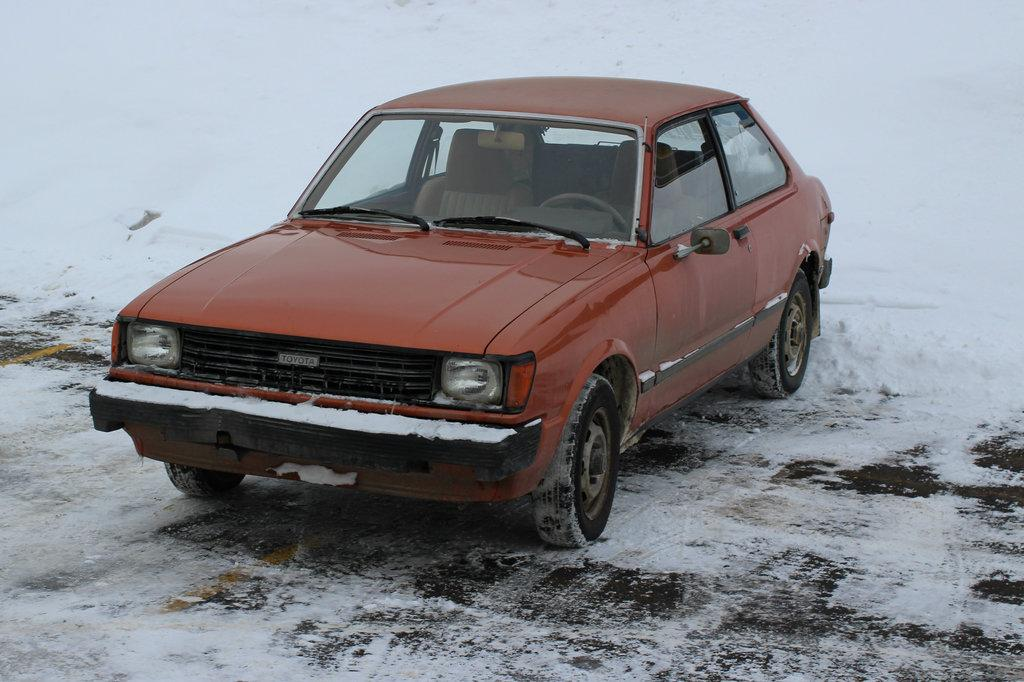What color is the car in the image? The car in the image is red. What is the condition of the ground in the image? There is snow on the ground in the image. What type of lead can be seen in the image? There is no lead present in the image. Can you describe the group of jellyfish in the image? There are no jellyfish present in the image. 